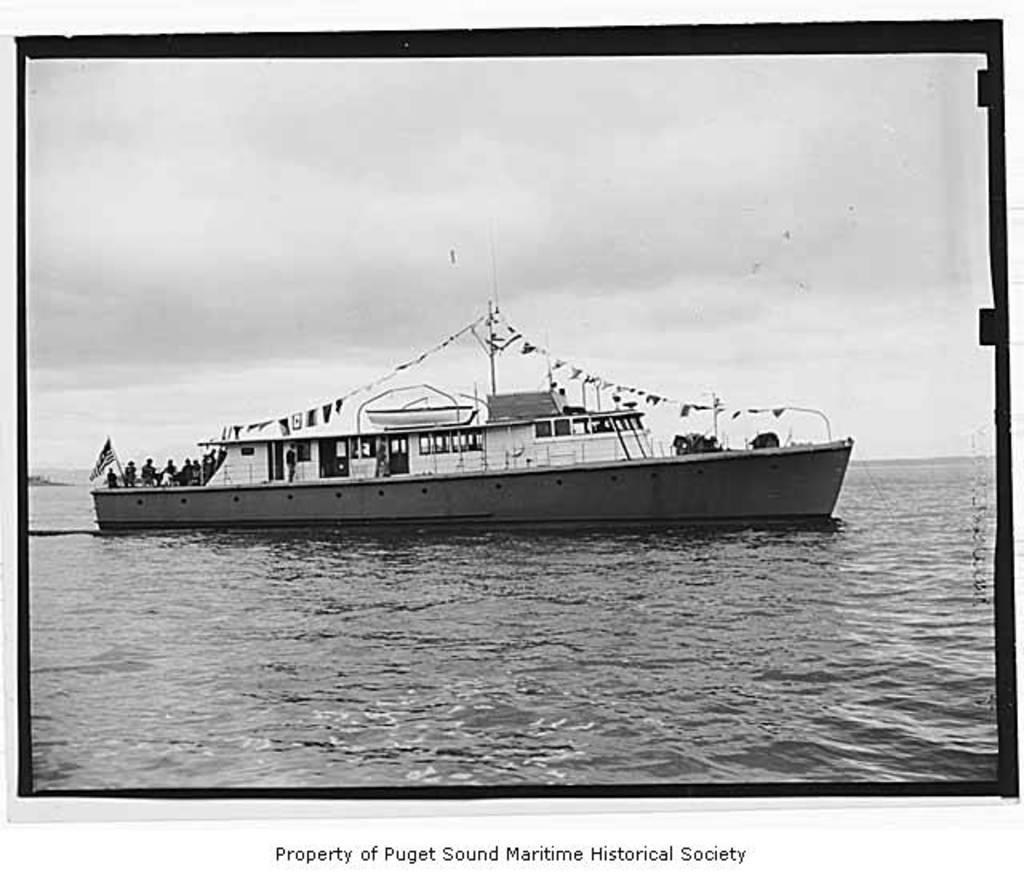Provide a one-sentence caption for the provided image. An old cruise ship is sailing in the ocean and its labeled Property of Puget Sound Maritime Historical Society. 